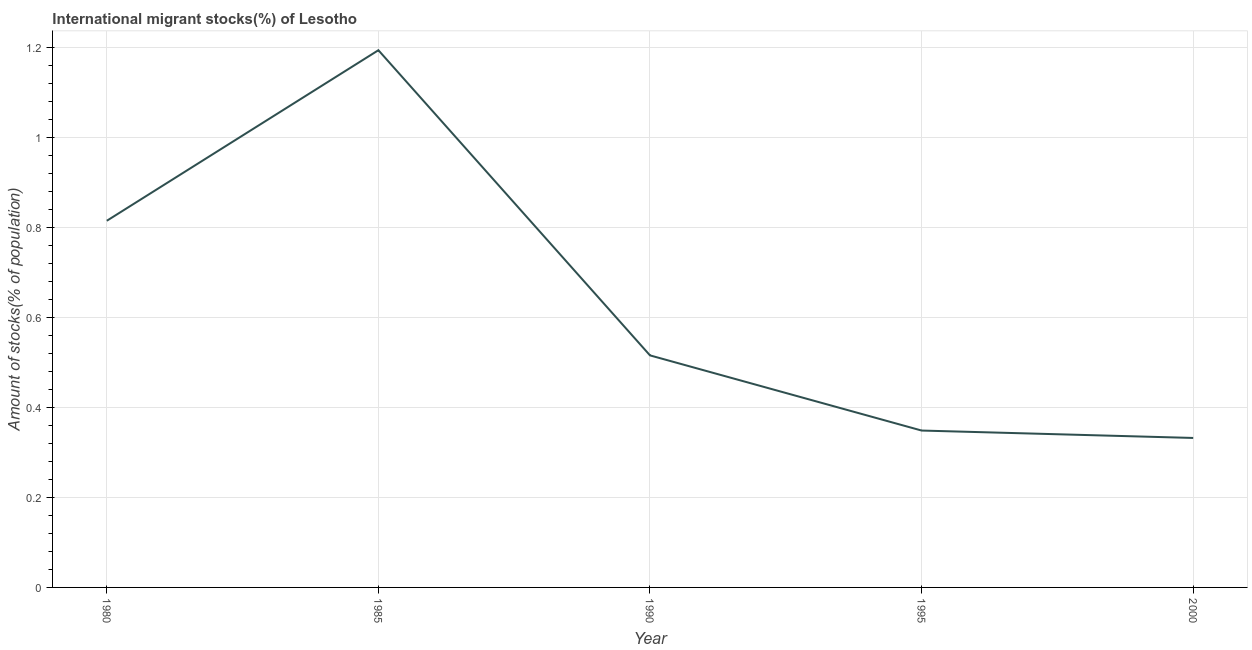What is the number of international migrant stocks in 1980?
Your response must be concise. 0.81. Across all years, what is the maximum number of international migrant stocks?
Give a very brief answer. 1.19. Across all years, what is the minimum number of international migrant stocks?
Offer a very short reply. 0.33. What is the sum of the number of international migrant stocks?
Ensure brevity in your answer.  3.21. What is the difference between the number of international migrant stocks in 1985 and 2000?
Offer a very short reply. 0.86. What is the average number of international migrant stocks per year?
Your answer should be compact. 0.64. What is the median number of international migrant stocks?
Make the answer very short. 0.52. What is the ratio of the number of international migrant stocks in 1990 to that in 1995?
Make the answer very short. 1.48. Is the number of international migrant stocks in 1980 less than that in 2000?
Offer a very short reply. No. What is the difference between the highest and the second highest number of international migrant stocks?
Your answer should be compact. 0.38. Is the sum of the number of international migrant stocks in 1980 and 1995 greater than the maximum number of international migrant stocks across all years?
Offer a very short reply. No. What is the difference between the highest and the lowest number of international migrant stocks?
Keep it short and to the point. 0.86. How many lines are there?
Offer a terse response. 1. Are the values on the major ticks of Y-axis written in scientific E-notation?
Your answer should be very brief. No. Does the graph contain any zero values?
Provide a succinct answer. No. What is the title of the graph?
Your answer should be compact. International migrant stocks(%) of Lesotho. What is the label or title of the Y-axis?
Your answer should be compact. Amount of stocks(% of population). What is the Amount of stocks(% of population) of 1980?
Make the answer very short. 0.81. What is the Amount of stocks(% of population) in 1985?
Provide a succinct answer. 1.19. What is the Amount of stocks(% of population) in 1990?
Give a very brief answer. 0.52. What is the Amount of stocks(% of population) of 1995?
Your answer should be compact. 0.35. What is the Amount of stocks(% of population) in 2000?
Provide a short and direct response. 0.33. What is the difference between the Amount of stocks(% of population) in 1980 and 1985?
Offer a very short reply. -0.38. What is the difference between the Amount of stocks(% of population) in 1980 and 1990?
Ensure brevity in your answer.  0.3. What is the difference between the Amount of stocks(% of population) in 1980 and 1995?
Keep it short and to the point. 0.47. What is the difference between the Amount of stocks(% of population) in 1980 and 2000?
Offer a very short reply. 0.48. What is the difference between the Amount of stocks(% of population) in 1985 and 1990?
Ensure brevity in your answer.  0.68. What is the difference between the Amount of stocks(% of population) in 1985 and 1995?
Your answer should be very brief. 0.85. What is the difference between the Amount of stocks(% of population) in 1985 and 2000?
Your response must be concise. 0.86. What is the difference between the Amount of stocks(% of population) in 1990 and 1995?
Ensure brevity in your answer.  0.17. What is the difference between the Amount of stocks(% of population) in 1990 and 2000?
Your response must be concise. 0.18. What is the difference between the Amount of stocks(% of population) in 1995 and 2000?
Keep it short and to the point. 0.02. What is the ratio of the Amount of stocks(% of population) in 1980 to that in 1985?
Offer a very short reply. 0.68. What is the ratio of the Amount of stocks(% of population) in 1980 to that in 1990?
Provide a succinct answer. 1.58. What is the ratio of the Amount of stocks(% of population) in 1980 to that in 1995?
Offer a terse response. 2.34. What is the ratio of the Amount of stocks(% of population) in 1980 to that in 2000?
Your answer should be compact. 2.45. What is the ratio of the Amount of stocks(% of population) in 1985 to that in 1990?
Provide a succinct answer. 2.31. What is the ratio of the Amount of stocks(% of population) in 1985 to that in 1995?
Your response must be concise. 3.42. What is the ratio of the Amount of stocks(% of population) in 1985 to that in 2000?
Your answer should be very brief. 3.59. What is the ratio of the Amount of stocks(% of population) in 1990 to that in 1995?
Your answer should be compact. 1.48. What is the ratio of the Amount of stocks(% of population) in 1990 to that in 2000?
Keep it short and to the point. 1.55. 